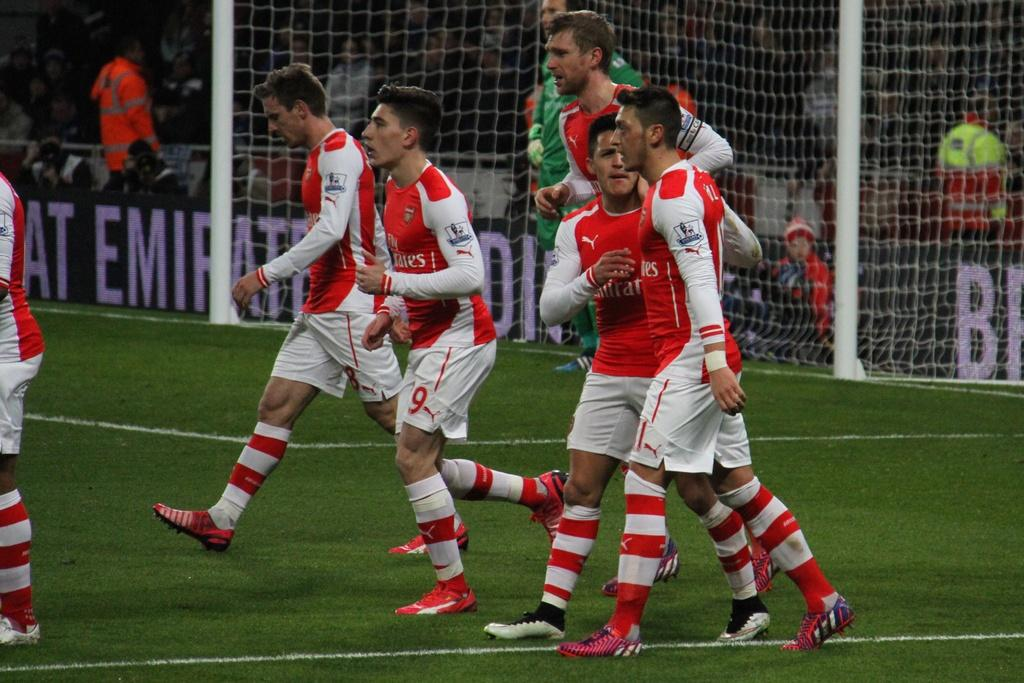<image>
Present a compact description of the photo's key features. a group of soccer players with emirates on their shirts 